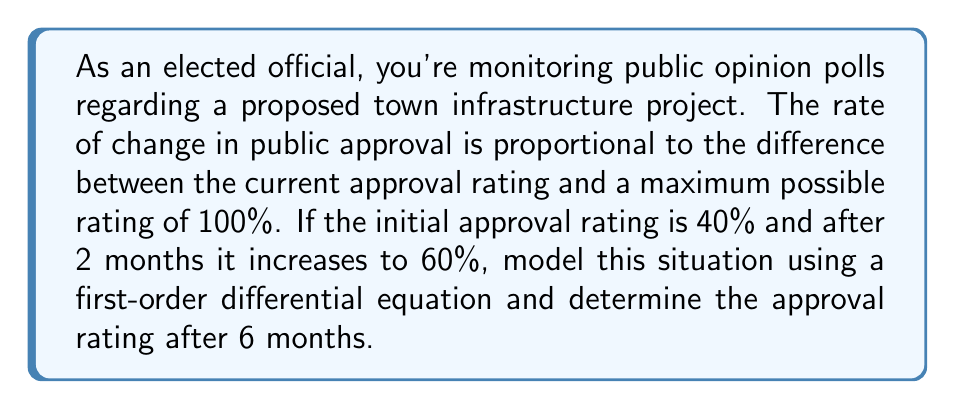Can you solve this math problem? Let's approach this step-by-step:

1) Let $P(t)$ be the approval rating at time $t$ (in months). We're given that:
   $P(0) = 40\%$ and $P(2) = 60\%$

2) The rate of change is proportional to the difference between the current rating and 100%:
   $$\frac{dP}{dt} = k(100 - P)$$
   where $k$ is a constant.

3) This is a separable first-order differential equation. Let's solve it:
   $$\frac{dP}{100 - P} = k dt$$

4) Integrating both sides:
   $$-\ln|100 - P| = kt + C$$

5) Solving for $P$:
   $$P = 100 - Ae^{-kt}$$
   where $A = e^{-C}$

6) Using the initial condition $P(0) = 40$:
   $$40 = 100 - A$$
   $$A = 60$$

7) So our solution is:
   $$P = 100 - 60e^{-kt}$$

8) Now use $P(2) = 60$ to find $k$:
   $$60 = 100 - 60e^{-2k}$$
   $$\frac{2}{3} = e^{-2k}$$
   $$k = \frac{\ln(3/2)}{2} \approx 0.2027$$

9) Our final model is:
   $$P = 100 - 60e^{-0.2027t}$$

10) To find $P(6)$, we simply plug in $t = 6$:
    $$P(6) = 100 - 60e^{-0.2027(6)} \approx 79.88\%$$
Answer: After 6 months, the approval rating will be approximately 79.88%. 